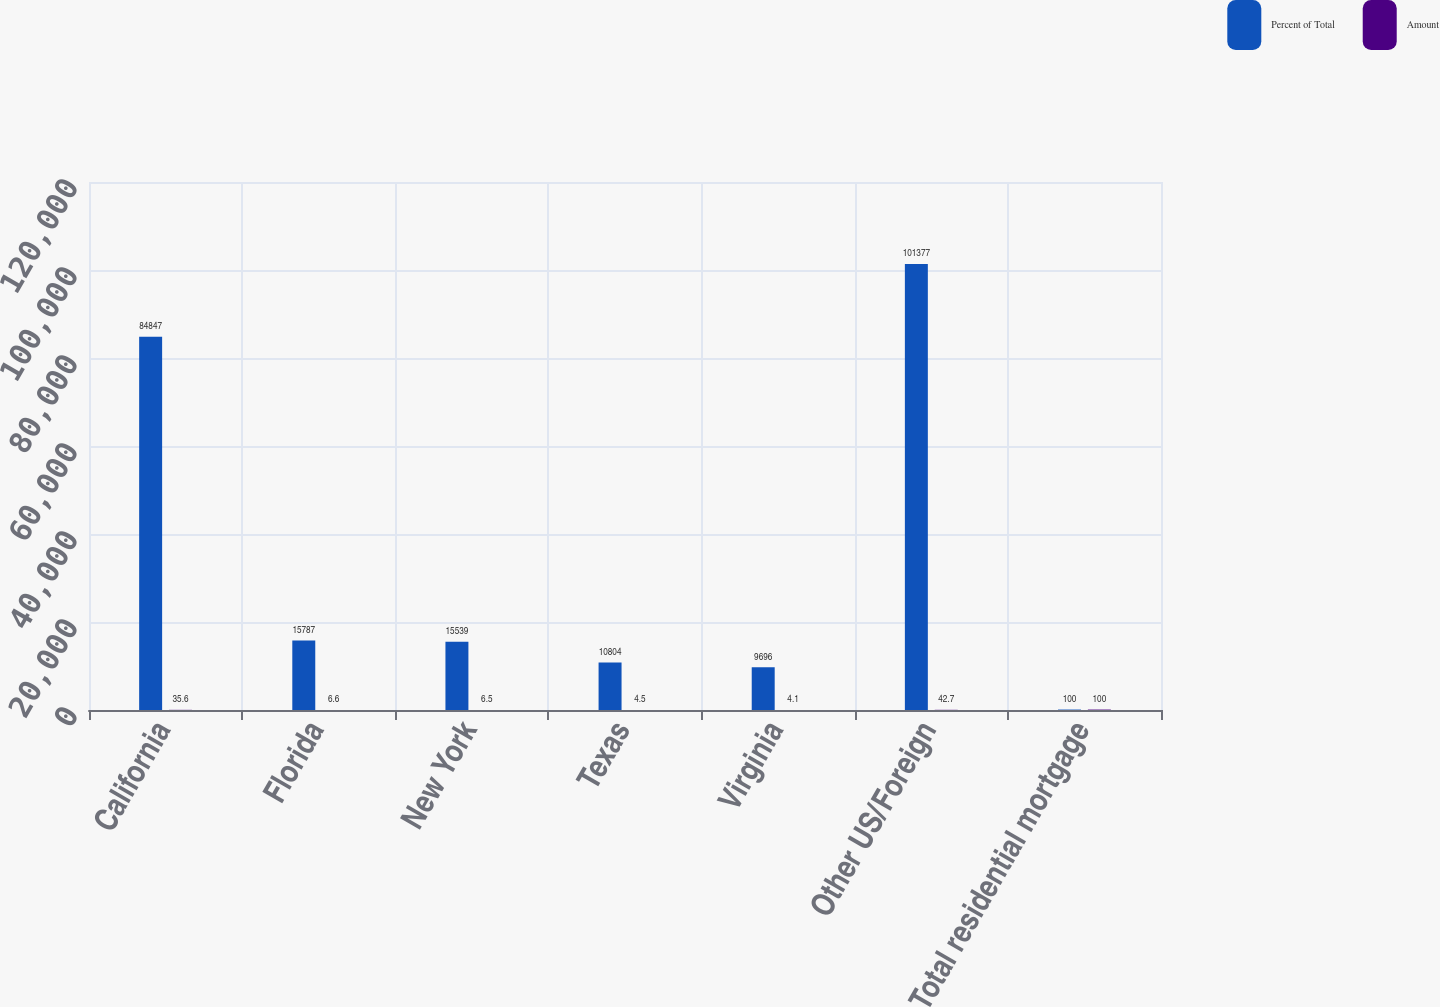Convert chart to OTSL. <chart><loc_0><loc_0><loc_500><loc_500><stacked_bar_chart><ecel><fcel>California<fcel>Florida<fcel>New York<fcel>Texas<fcel>Virginia<fcel>Other US/Foreign<fcel>Total residential mortgage<nl><fcel>Percent of Total<fcel>84847<fcel>15787<fcel>15539<fcel>10804<fcel>9696<fcel>101377<fcel>100<nl><fcel>Amount<fcel>35.6<fcel>6.6<fcel>6.5<fcel>4.5<fcel>4.1<fcel>42.7<fcel>100<nl></chart> 